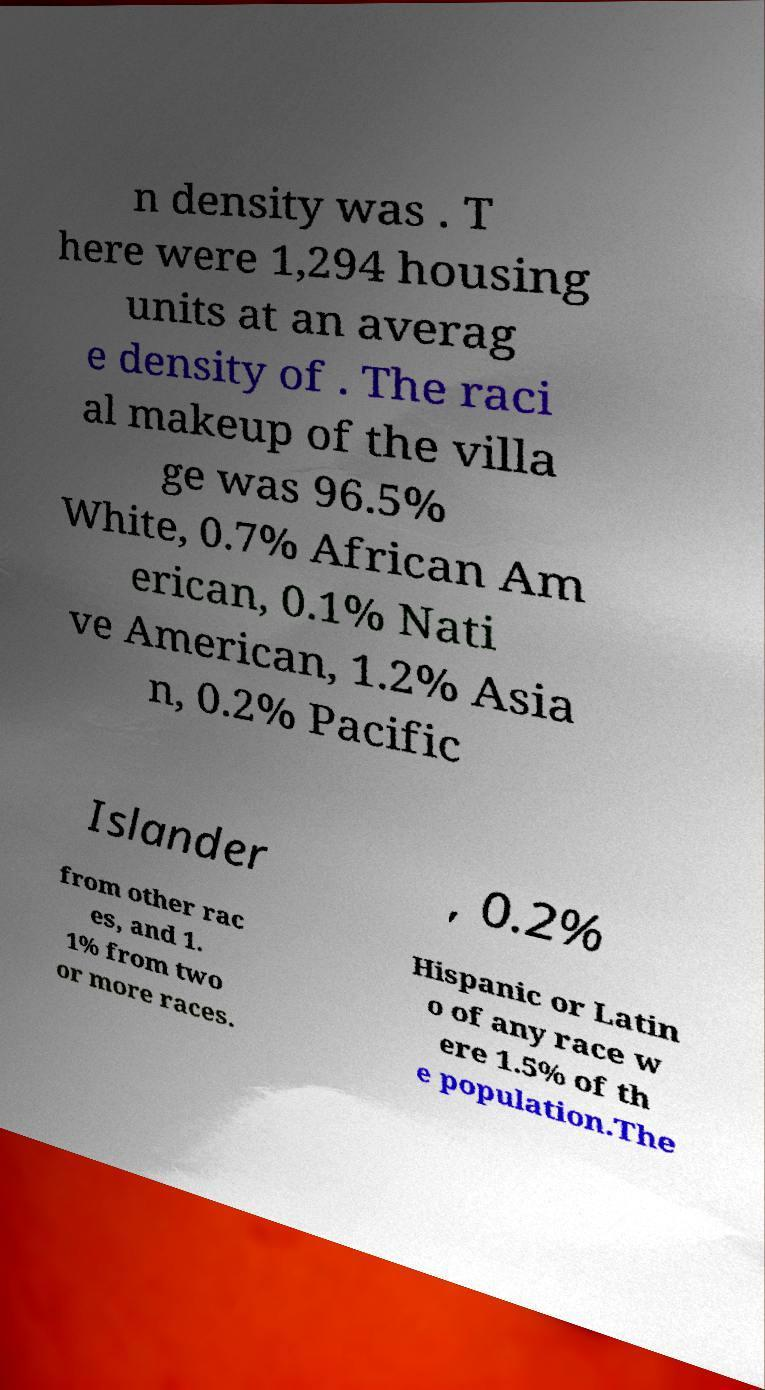For documentation purposes, I need the text within this image transcribed. Could you provide that? n density was . T here were 1,294 housing units at an averag e density of . The raci al makeup of the villa ge was 96.5% White, 0.7% African Am erican, 0.1% Nati ve American, 1.2% Asia n, 0.2% Pacific Islander , 0.2% from other rac es, and 1. 1% from two or more races. Hispanic or Latin o of any race w ere 1.5% of th e population.The 